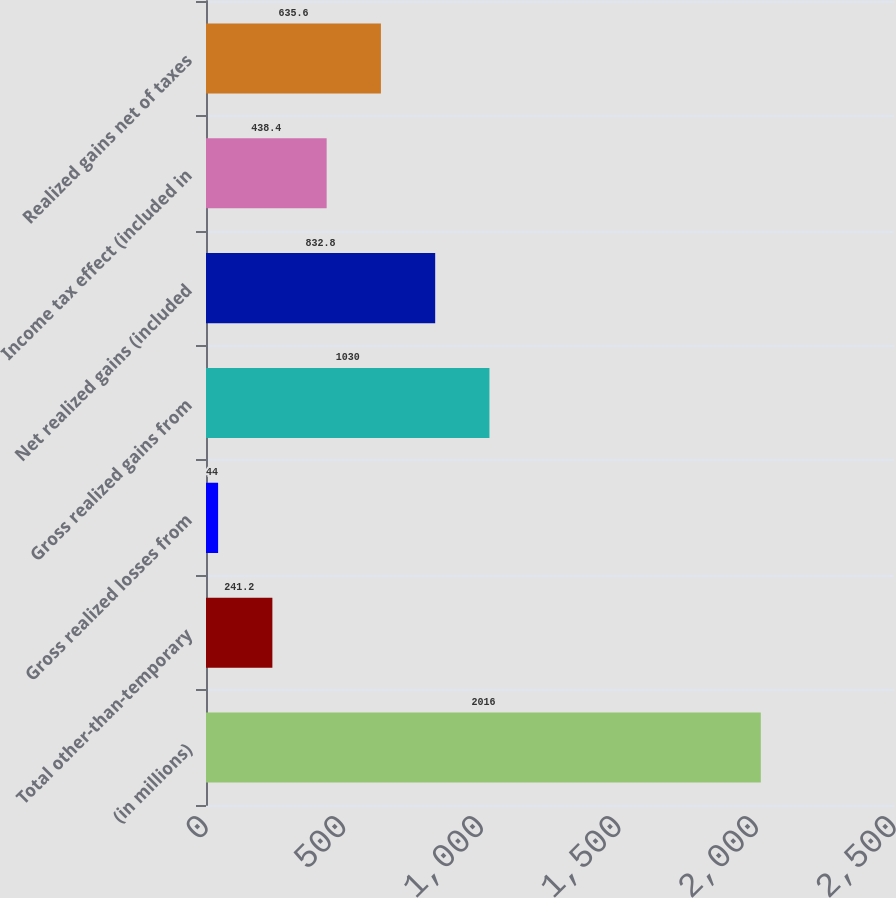<chart> <loc_0><loc_0><loc_500><loc_500><bar_chart><fcel>(in millions)<fcel>Total other-than-temporary<fcel>Gross realized losses from<fcel>Gross realized gains from<fcel>Net realized gains (included<fcel>Income tax effect (included in<fcel>Realized gains net of taxes<nl><fcel>2016<fcel>241.2<fcel>44<fcel>1030<fcel>832.8<fcel>438.4<fcel>635.6<nl></chart> 